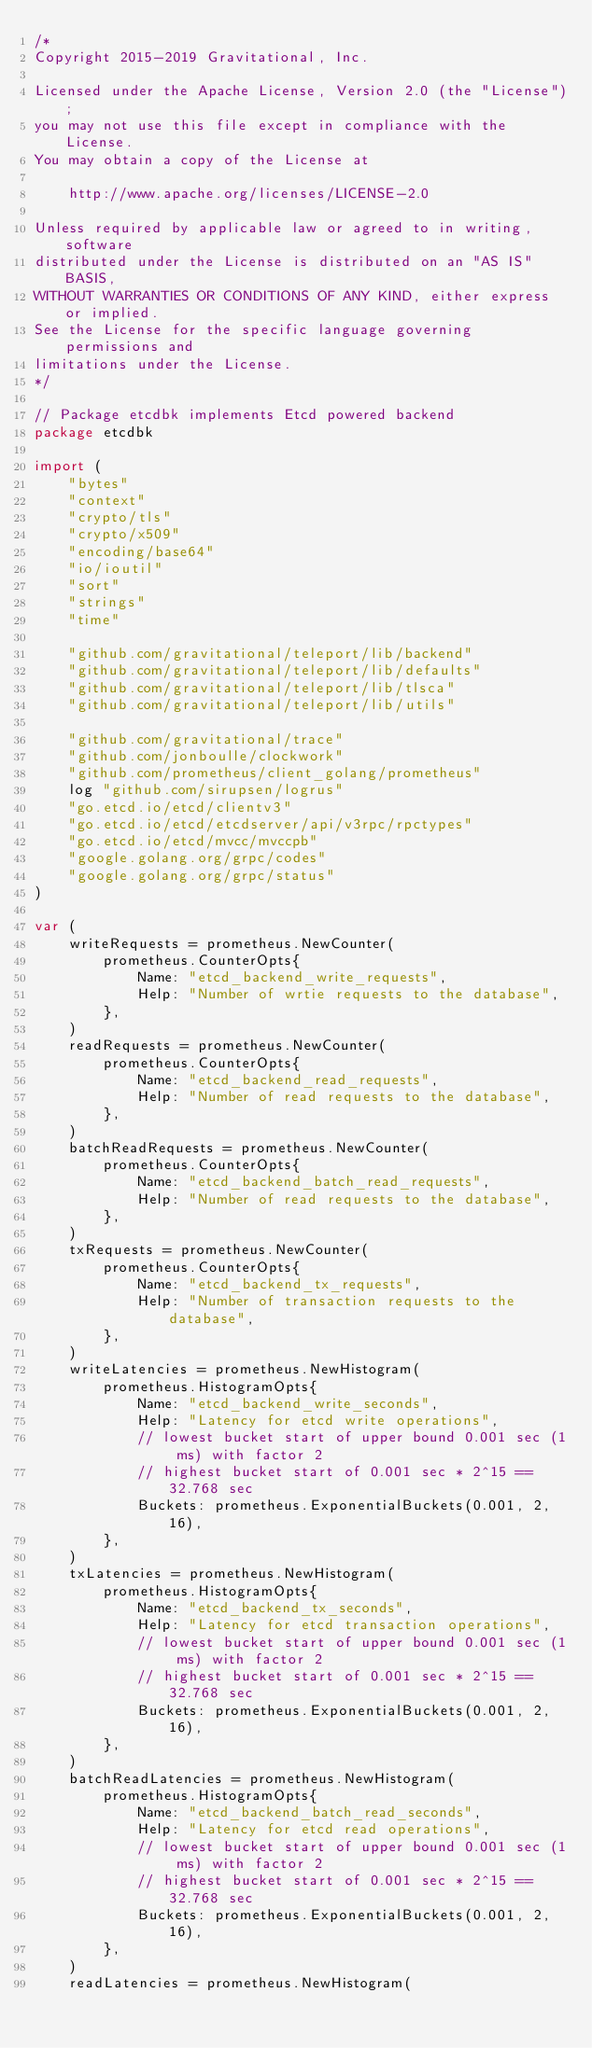<code> <loc_0><loc_0><loc_500><loc_500><_Go_>/*
Copyright 2015-2019 Gravitational, Inc.

Licensed under the Apache License, Version 2.0 (the "License");
you may not use this file except in compliance with the License.
You may obtain a copy of the License at

    http://www.apache.org/licenses/LICENSE-2.0

Unless required by applicable law or agreed to in writing, software
distributed under the License is distributed on an "AS IS" BASIS,
WITHOUT WARRANTIES OR CONDITIONS OF ANY KIND, either express or implied.
See the License for the specific language governing permissions and
limitations under the License.
*/

// Package etcdbk implements Etcd powered backend
package etcdbk

import (
	"bytes"
	"context"
	"crypto/tls"
	"crypto/x509"
	"encoding/base64"
	"io/ioutil"
	"sort"
	"strings"
	"time"

	"github.com/gravitational/teleport/lib/backend"
	"github.com/gravitational/teleport/lib/defaults"
	"github.com/gravitational/teleport/lib/tlsca"
	"github.com/gravitational/teleport/lib/utils"

	"github.com/gravitational/trace"
	"github.com/jonboulle/clockwork"
	"github.com/prometheus/client_golang/prometheus"
	log "github.com/sirupsen/logrus"
	"go.etcd.io/etcd/clientv3"
	"go.etcd.io/etcd/etcdserver/api/v3rpc/rpctypes"
	"go.etcd.io/etcd/mvcc/mvccpb"
	"google.golang.org/grpc/codes"
	"google.golang.org/grpc/status"
)

var (
	writeRequests = prometheus.NewCounter(
		prometheus.CounterOpts{
			Name: "etcd_backend_write_requests",
			Help: "Number of wrtie requests to the database",
		},
	)
	readRequests = prometheus.NewCounter(
		prometheus.CounterOpts{
			Name: "etcd_backend_read_requests",
			Help: "Number of read requests to the database",
		},
	)
	batchReadRequests = prometheus.NewCounter(
		prometheus.CounterOpts{
			Name: "etcd_backend_batch_read_requests",
			Help: "Number of read requests to the database",
		},
	)
	txRequests = prometheus.NewCounter(
		prometheus.CounterOpts{
			Name: "etcd_backend_tx_requests",
			Help: "Number of transaction requests to the database",
		},
	)
	writeLatencies = prometheus.NewHistogram(
		prometheus.HistogramOpts{
			Name: "etcd_backend_write_seconds",
			Help: "Latency for etcd write operations",
			// lowest bucket start of upper bound 0.001 sec (1 ms) with factor 2
			// highest bucket start of 0.001 sec * 2^15 == 32.768 sec
			Buckets: prometheus.ExponentialBuckets(0.001, 2, 16),
		},
	)
	txLatencies = prometheus.NewHistogram(
		prometheus.HistogramOpts{
			Name: "etcd_backend_tx_seconds",
			Help: "Latency for etcd transaction operations",
			// lowest bucket start of upper bound 0.001 sec (1 ms) with factor 2
			// highest bucket start of 0.001 sec * 2^15 == 32.768 sec
			Buckets: prometheus.ExponentialBuckets(0.001, 2, 16),
		},
	)
	batchReadLatencies = prometheus.NewHistogram(
		prometheus.HistogramOpts{
			Name: "etcd_backend_batch_read_seconds",
			Help: "Latency for etcd read operations",
			// lowest bucket start of upper bound 0.001 sec (1 ms) with factor 2
			// highest bucket start of 0.001 sec * 2^15 == 32.768 sec
			Buckets: prometheus.ExponentialBuckets(0.001, 2, 16),
		},
	)
	readLatencies = prometheus.NewHistogram(</code> 